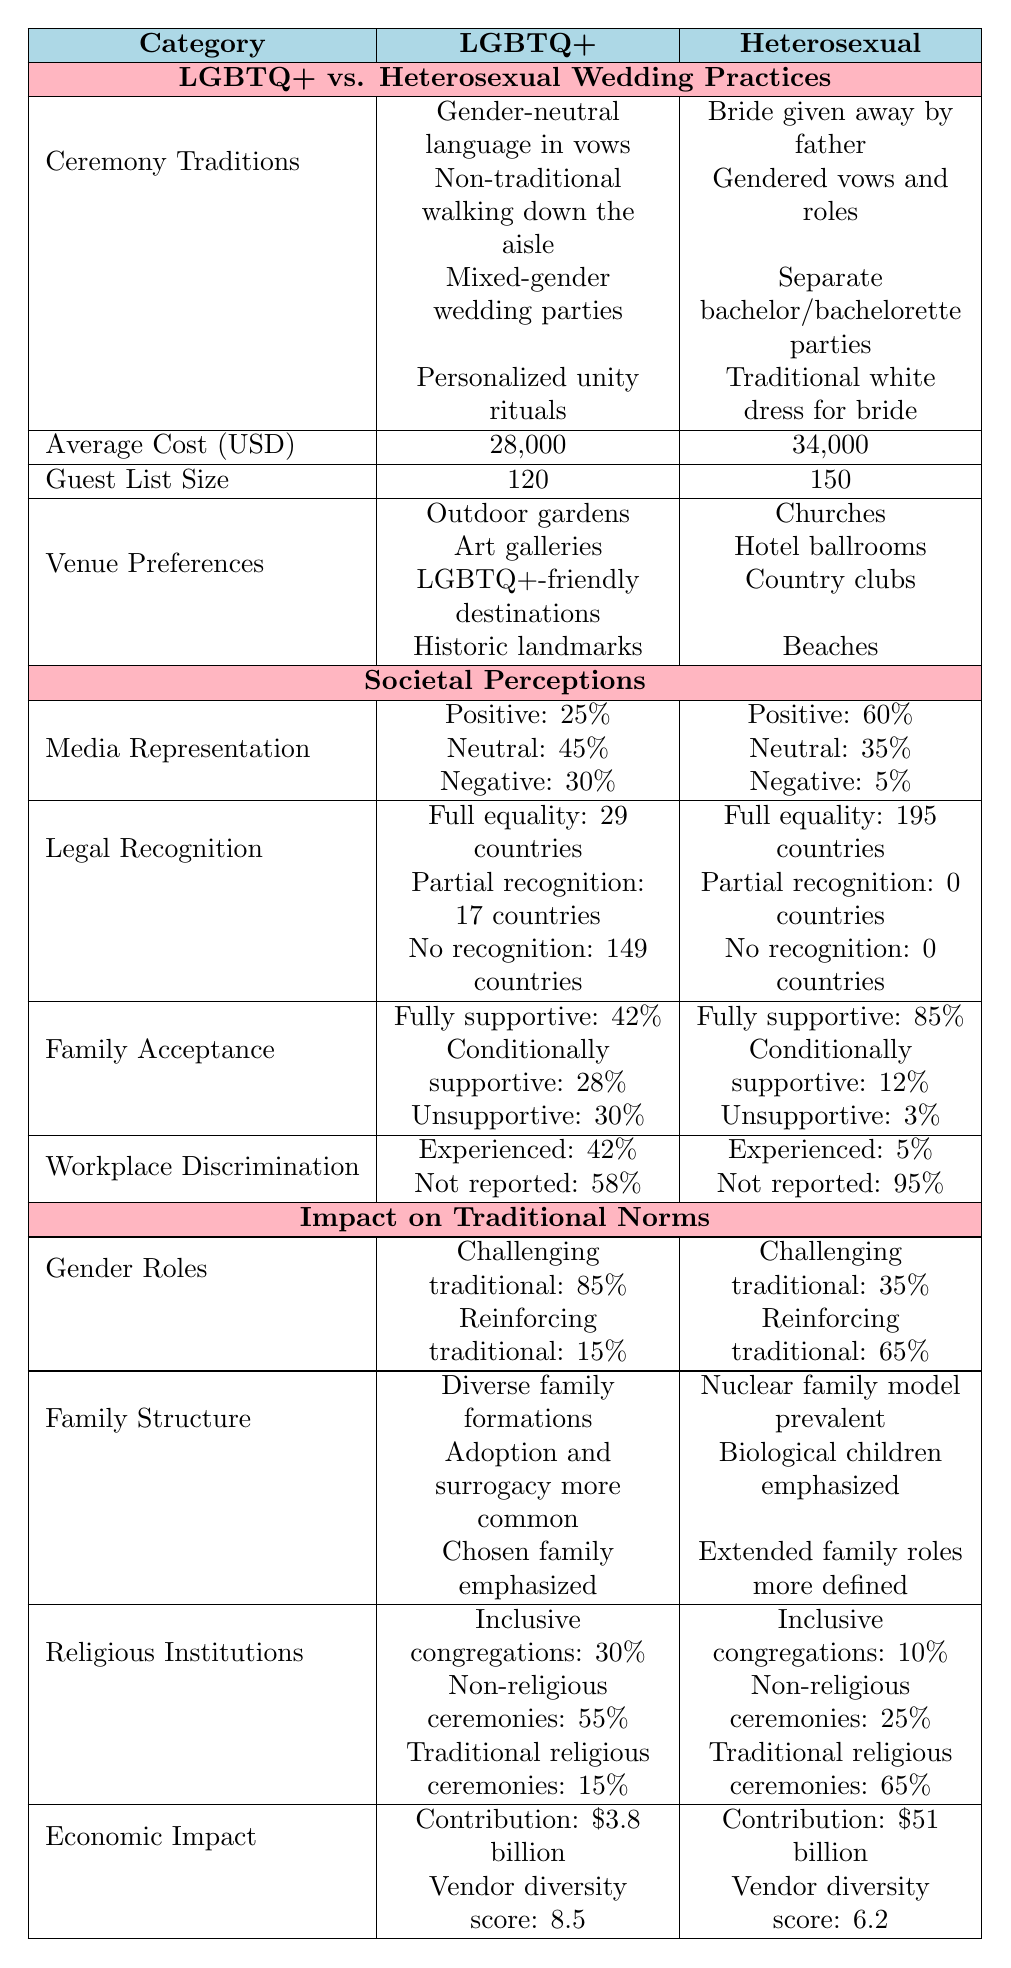What's the average cost of LGBTQ+ weddings? The average cost for LGBTQ+ weddings is listed as 28,000 USD in the table.
Answer: 28,000 USD What percentage of LGBTQ+ media representation is positive? The table shows that 25% of media portrayals of LGBTQ+ individuals are positive.
Answer: 25% What is the difference in guest list size between LGBTQ+ and heterosexual weddings? The guest list size for LGBTQ+ weddings is 120 and for heterosexual weddings is 150. The difference is 150 - 120 = 30.
Answer: 30 Are LGBTQ+ wedding practices more likely to challenge traditional gender roles? The table indicates that LGBTQ+ weddings have 85% challenging traditional roles, while heterosexual weddings have only 35%. Thus, LGBTQ+ practices are more likely to challenge traditional roles.
Answer: Yes What is the total number of countries with no legal recognition of LGBTQ+ marriage? According to the table, there are 149 countries with no recognition of LGBTQ+ marriage.
Answer: 149 countries How many more countries have full marriage equality for heterosexuals compared to LGBTQ+ individuals? Heterosexuals have full marriage equality in 195 countries while LGBTQ+ individuals have it in 29, so the difference is 195 - 29 = 166 countries.
Answer: 166 countries What percentage of LGBTQ+ individuals are fully supported by their families? The table states that 42% of LGBTQ+ individuals are fully supported by their families.
Answer: 42% What is the average vendor diversity score for LGBTQ+ weddings compared to heterosexual weddings? The table lists the average vendor diversity score for LGBTQ+ weddings as 8.5 and for heterosexual weddings as 6.2.
Answer: LGBTQ+: 8.5, Heterosexual: 6.2 Which wedding group has a higher rate of experienced discrimination in the workplace? The table indicates that 42% of LGBTQ+ individuals report experienced discrimination, compared to only 5% of heterosexuals. Therefore, LGBTQ+ individuals have a higher rate of discrimination.
Answer: LGBTQ+ What is the proportion of non-religious ceremonies in LGBTQ+ weddings compared to heterosexual weddings? The table shows that 55% of LGBTQ+ weddings are non-religious, while 25% of heterosexual weddings have non-religious ceremonies. Thus, a higher proportion of LGBTQ+ weddings are non-religious.
Answer: LGBTQ+ have a higher proportion 